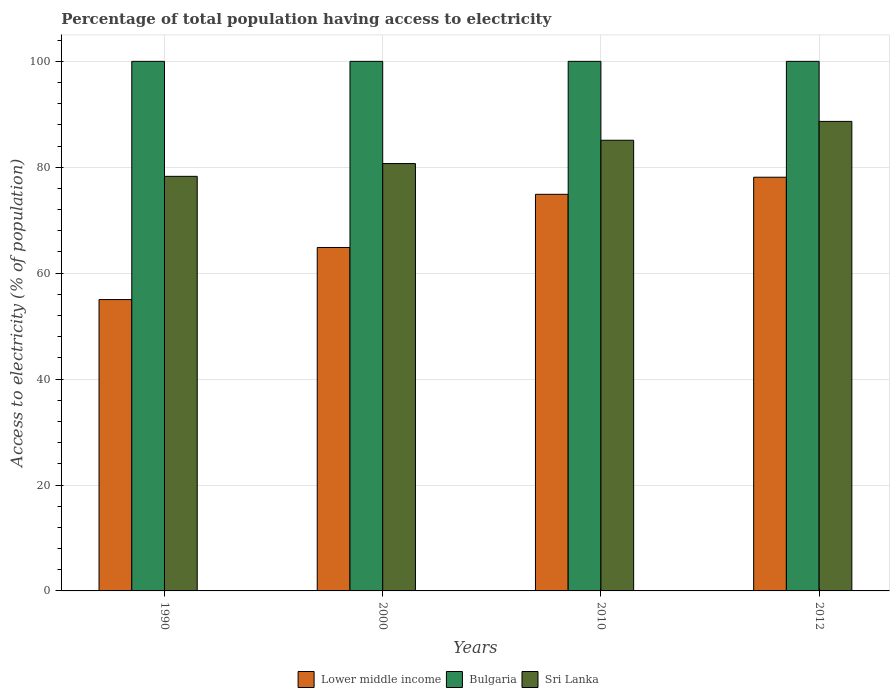How many different coloured bars are there?
Keep it short and to the point. 3. How many groups of bars are there?
Make the answer very short. 4. Are the number of bars per tick equal to the number of legend labels?
Make the answer very short. Yes. Are the number of bars on each tick of the X-axis equal?
Offer a very short reply. Yes. How many bars are there on the 4th tick from the left?
Provide a short and direct response. 3. In how many cases, is the number of bars for a given year not equal to the number of legend labels?
Ensure brevity in your answer.  0. What is the percentage of population that have access to electricity in Sri Lanka in 2012?
Your answer should be very brief. 88.66. Across all years, what is the maximum percentage of population that have access to electricity in Sri Lanka?
Make the answer very short. 88.66. Across all years, what is the minimum percentage of population that have access to electricity in Lower middle income?
Provide a short and direct response. 55.02. In which year was the percentage of population that have access to electricity in Lower middle income maximum?
Your answer should be very brief. 2012. In which year was the percentage of population that have access to electricity in Sri Lanka minimum?
Offer a terse response. 1990. What is the total percentage of population that have access to electricity in Bulgaria in the graph?
Your response must be concise. 400. What is the difference between the percentage of population that have access to electricity in Lower middle income in 1990 and that in 2010?
Ensure brevity in your answer.  -19.87. What is the difference between the percentage of population that have access to electricity in Sri Lanka in 2000 and the percentage of population that have access to electricity in Lower middle income in 1990?
Your response must be concise. 25.68. What is the average percentage of population that have access to electricity in Sri Lanka per year?
Provide a succinct answer. 83.19. In the year 2000, what is the difference between the percentage of population that have access to electricity in Bulgaria and percentage of population that have access to electricity in Sri Lanka?
Provide a short and direct response. 19.3. In how many years, is the percentage of population that have access to electricity in Lower middle income greater than 24 %?
Your response must be concise. 4. Is the percentage of population that have access to electricity in Bulgaria in 2000 less than that in 2010?
Your answer should be compact. No. What is the difference between the highest and the second highest percentage of population that have access to electricity in Lower middle income?
Provide a succinct answer. 3.23. What is the difference between the highest and the lowest percentage of population that have access to electricity in Sri Lanka?
Your answer should be very brief. 10.37. What does the 1st bar from the left in 2010 represents?
Provide a short and direct response. Lower middle income. What does the 3rd bar from the right in 2012 represents?
Offer a terse response. Lower middle income. How many bars are there?
Your answer should be very brief. 12. How many years are there in the graph?
Provide a succinct answer. 4. Are the values on the major ticks of Y-axis written in scientific E-notation?
Offer a very short reply. No. Does the graph contain any zero values?
Keep it short and to the point. No. Where does the legend appear in the graph?
Keep it short and to the point. Bottom center. How many legend labels are there?
Your answer should be very brief. 3. What is the title of the graph?
Your response must be concise. Percentage of total population having access to electricity. Does "Cayman Islands" appear as one of the legend labels in the graph?
Provide a short and direct response. No. What is the label or title of the Y-axis?
Provide a succinct answer. Access to electricity (% of population). What is the Access to electricity (% of population) in Lower middle income in 1990?
Your answer should be compact. 55.02. What is the Access to electricity (% of population) of Bulgaria in 1990?
Provide a short and direct response. 100. What is the Access to electricity (% of population) of Sri Lanka in 1990?
Your response must be concise. 78.29. What is the Access to electricity (% of population) in Lower middle income in 2000?
Your response must be concise. 64.85. What is the Access to electricity (% of population) of Sri Lanka in 2000?
Provide a short and direct response. 80.7. What is the Access to electricity (% of population) in Lower middle income in 2010?
Your answer should be compact. 74.89. What is the Access to electricity (% of population) in Bulgaria in 2010?
Ensure brevity in your answer.  100. What is the Access to electricity (% of population) in Sri Lanka in 2010?
Provide a short and direct response. 85.1. What is the Access to electricity (% of population) in Lower middle income in 2012?
Your answer should be very brief. 78.12. What is the Access to electricity (% of population) in Sri Lanka in 2012?
Give a very brief answer. 88.66. Across all years, what is the maximum Access to electricity (% of population) of Lower middle income?
Make the answer very short. 78.12. Across all years, what is the maximum Access to electricity (% of population) of Sri Lanka?
Offer a very short reply. 88.66. Across all years, what is the minimum Access to electricity (% of population) in Lower middle income?
Give a very brief answer. 55.02. Across all years, what is the minimum Access to electricity (% of population) in Bulgaria?
Ensure brevity in your answer.  100. Across all years, what is the minimum Access to electricity (% of population) in Sri Lanka?
Make the answer very short. 78.29. What is the total Access to electricity (% of population) of Lower middle income in the graph?
Offer a terse response. 272.88. What is the total Access to electricity (% of population) of Sri Lanka in the graph?
Ensure brevity in your answer.  332.75. What is the difference between the Access to electricity (% of population) in Lower middle income in 1990 and that in 2000?
Provide a short and direct response. -9.84. What is the difference between the Access to electricity (% of population) of Bulgaria in 1990 and that in 2000?
Your answer should be compact. 0. What is the difference between the Access to electricity (% of population) of Sri Lanka in 1990 and that in 2000?
Give a very brief answer. -2.41. What is the difference between the Access to electricity (% of population) in Lower middle income in 1990 and that in 2010?
Offer a terse response. -19.87. What is the difference between the Access to electricity (% of population) of Bulgaria in 1990 and that in 2010?
Ensure brevity in your answer.  0. What is the difference between the Access to electricity (% of population) in Sri Lanka in 1990 and that in 2010?
Your answer should be very brief. -6.81. What is the difference between the Access to electricity (% of population) of Lower middle income in 1990 and that in 2012?
Your response must be concise. -23.1. What is the difference between the Access to electricity (% of population) of Sri Lanka in 1990 and that in 2012?
Give a very brief answer. -10.37. What is the difference between the Access to electricity (% of population) in Lower middle income in 2000 and that in 2010?
Make the answer very short. -10.04. What is the difference between the Access to electricity (% of population) of Sri Lanka in 2000 and that in 2010?
Provide a succinct answer. -4.4. What is the difference between the Access to electricity (% of population) in Lower middle income in 2000 and that in 2012?
Your response must be concise. -13.27. What is the difference between the Access to electricity (% of population) of Sri Lanka in 2000 and that in 2012?
Your response must be concise. -7.96. What is the difference between the Access to electricity (% of population) of Lower middle income in 2010 and that in 2012?
Ensure brevity in your answer.  -3.23. What is the difference between the Access to electricity (% of population) in Sri Lanka in 2010 and that in 2012?
Keep it short and to the point. -3.56. What is the difference between the Access to electricity (% of population) of Lower middle income in 1990 and the Access to electricity (% of population) of Bulgaria in 2000?
Ensure brevity in your answer.  -44.98. What is the difference between the Access to electricity (% of population) in Lower middle income in 1990 and the Access to electricity (% of population) in Sri Lanka in 2000?
Your response must be concise. -25.68. What is the difference between the Access to electricity (% of population) of Bulgaria in 1990 and the Access to electricity (% of population) of Sri Lanka in 2000?
Offer a very short reply. 19.3. What is the difference between the Access to electricity (% of population) in Lower middle income in 1990 and the Access to electricity (% of population) in Bulgaria in 2010?
Ensure brevity in your answer.  -44.98. What is the difference between the Access to electricity (% of population) of Lower middle income in 1990 and the Access to electricity (% of population) of Sri Lanka in 2010?
Keep it short and to the point. -30.08. What is the difference between the Access to electricity (% of population) of Lower middle income in 1990 and the Access to electricity (% of population) of Bulgaria in 2012?
Provide a succinct answer. -44.98. What is the difference between the Access to electricity (% of population) in Lower middle income in 1990 and the Access to electricity (% of population) in Sri Lanka in 2012?
Ensure brevity in your answer.  -33.65. What is the difference between the Access to electricity (% of population) of Bulgaria in 1990 and the Access to electricity (% of population) of Sri Lanka in 2012?
Make the answer very short. 11.34. What is the difference between the Access to electricity (% of population) of Lower middle income in 2000 and the Access to electricity (% of population) of Bulgaria in 2010?
Make the answer very short. -35.15. What is the difference between the Access to electricity (% of population) in Lower middle income in 2000 and the Access to electricity (% of population) in Sri Lanka in 2010?
Provide a succinct answer. -20.25. What is the difference between the Access to electricity (% of population) in Lower middle income in 2000 and the Access to electricity (% of population) in Bulgaria in 2012?
Keep it short and to the point. -35.15. What is the difference between the Access to electricity (% of population) of Lower middle income in 2000 and the Access to electricity (% of population) of Sri Lanka in 2012?
Provide a short and direct response. -23.81. What is the difference between the Access to electricity (% of population) of Bulgaria in 2000 and the Access to electricity (% of population) of Sri Lanka in 2012?
Your answer should be compact. 11.34. What is the difference between the Access to electricity (% of population) of Lower middle income in 2010 and the Access to electricity (% of population) of Bulgaria in 2012?
Offer a terse response. -25.11. What is the difference between the Access to electricity (% of population) of Lower middle income in 2010 and the Access to electricity (% of population) of Sri Lanka in 2012?
Your answer should be compact. -13.77. What is the difference between the Access to electricity (% of population) of Bulgaria in 2010 and the Access to electricity (% of population) of Sri Lanka in 2012?
Keep it short and to the point. 11.34. What is the average Access to electricity (% of population) of Lower middle income per year?
Offer a very short reply. 68.22. What is the average Access to electricity (% of population) in Sri Lanka per year?
Your answer should be compact. 83.19. In the year 1990, what is the difference between the Access to electricity (% of population) in Lower middle income and Access to electricity (% of population) in Bulgaria?
Keep it short and to the point. -44.98. In the year 1990, what is the difference between the Access to electricity (% of population) in Lower middle income and Access to electricity (% of population) in Sri Lanka?
Keep it short and to the point. -23.27. In the year 1990, what is the difference between the Access to electricity (% of population) in Bulgaria and Access to electricity (% of population) in Sri Lanka?
Ensure brevity in your answer.  21.71. In the year 2000, what is the difference between the Access to electricity (% of population) in Lower middle income and Access to electricity (% of population) in Bulgaria?
Ensure brevity in your answer.  -35.15. In the year 2000, what is the difference between the Access to electricity (% of population) in Lower middle income and Access to electricity (% of population) in Sri Lanka?
Provide a short and direct response. -15.85. In the year 2000, what is the difference between the Access to electricity (% of population) in Bulgaria and Access to electricity (% of population) in Sri Lanka?
Your answer should be compact. 19.3. In the year 2010, what is the difference between the Access to electricity (% of population) of Lower middle income and Access to electricity (% of population) of Bulgaria?
Your response must be concise. -25.11. In the year 2010, what is the difference between the Access to electricity (% of population) of Lower middle income and Access to electricity (% of population) of Sri Lanka?
Provide a short and direct response. -10.21. In the year 2012, what is the difference between the Access to electricity (% of population) in Lower middle income and Access to electricity (% of population) in Bulgaria?
Ensure brevity in your answer.  -21.88. In the year 2012, what is the difference between the Access to electricity (% of population) of Lower middle income and Access to electricity (% of population) of Sri Lanka?
Offer a terse response. -10.54. In the year 2012, what is the difference between the Access to electricity (% of population) in Bulgaria and Access to electricity (% of population) in Sri Lanka?
Your answer should be compact. 11.34. What is the ratio of the Access to electricity (% of population) of Lower middle income in 1990 to that in 2000?
Your answer should be compact. 0.85. What is the ratio of the Access to electricity (% of population) of Bulgaria in 1990 to that in 2000?
Offer a terse response. 1. What is the ratio of the Access to electricity (% of population) of Sri Lanka in 1990 to that in 2000?
Your answer should be very brief. 0.97. What is the ratio of the Access to electricity (% of population) in Lower middle income in 1990 to that in 2010?
Give a very brief answer. 0.73. What is the ratio of the Access to electricity (% of population) in Bulgaria in 1990 to that in 2010?
Your answer should be compact. 1. What is the ratio of the Access to electricity (% of population) in Sri Lanka in 1990 to that in 2010?
Your response must be concise. 0.92. What is the ratio of the Access to electricity (% of population) in Lower middle income in 1990 to that in 2012?
Provide a short and direct response. 0.7. What is the ratio of the Access to electricity (% of population) of Bulgaria in 1990 to that in 2012?
Provide a succinct answer. 1. What is the ratio of the Access to electricity (% of population) of Sri Lanka in 1990 to that in 2012?
Ensure brevity in your answer.  0.88. What is the ratio of the Access to electricity (% of population) in Lower middle income in 2000 to that in 2010?
Ensure brevity in your answer.  0.87. What is the ratio of the Access to electricity (% of population) of Sri Lanka in 2000 to that in 2010?
Keep it short and to the point. 0.95. What is the ratio of the Access to electricity (% of population) of Lower middle income in 2000 to that in 2012?
Your answer should be very brief. 0.83. What is the ratio of the Access to electricity (% of population) in Sri Lanka in 2000 to that in 2012?
Make the answer very short. 0.91. What is the ratio of the Access to electricity (% of population) in Lower middle income in 2010 to that in 2012?
Provide a succinct answer. 0.96. What is the ratio of the Access to electricity (% of population) of Bulgaria in 2010 to that in 2012?
Make the answer very short. 1. What is the ratio of the Access to electricity (% of population) of Sri Lanka in 2010 to that in 2012?
Your answer should be compact. 0.96. What is the difference between the highest and the second highest Access to electricity (% of population) in Lower middle income?
Make the answer very short. 3.23. What is the difference between the highest and the second highest Access to electricity (% of population) in Sri Lanka?
Your answer should be compact. 3.56. What is the difference between the highest and the lowest Access to electricity (% of population) in Lower middle income?
Provide a succinct answer. 23.1. What is the difference between the highest and the lowest Access to electricity (% of population) in Bulgaria?
Give a very brief answer. 0. What is the difference between the highest and the lowest Access to electricity (% of population) in Sri Lanka?
Your answer should be compact. 10.37. 